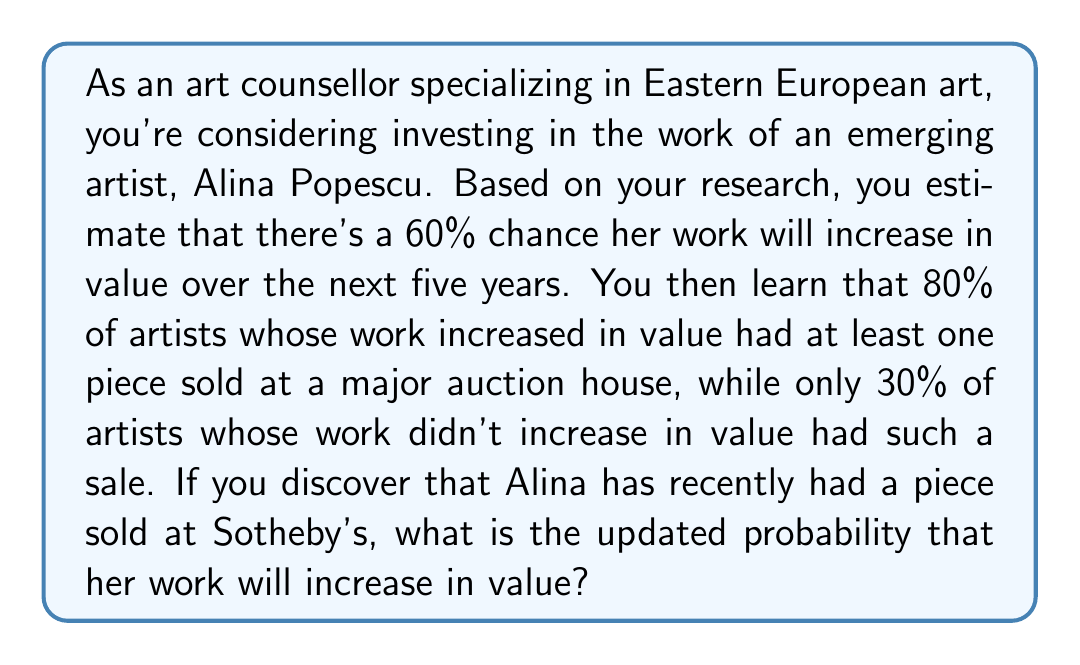Can you answer this question? This problem can be solved using Bayes' theorem. Let's define our events:

A: Alina's work increases in value
B: Alina has a piece sold at a major auction house

We're given:
$P(A) = 0.60$ (prior probability)
$P(B|A) = 0.80$ (probability of auction sale given value increase)
$P(B|\neg A) = 0.30$ (probability of auction sale given no value increase)
$P(B)$ (we've observed this event)

We want to find $P(A|B)$, the probability of value increase given the auction sale.

Bayes' theorem states:

$$P(A|B) = \frac{P(B|A) \cdot P(A)}{P(B)}$$

To find $P(B)$, we use the law of total probability:

$$P(B) = P(B|A) \cdot P(A) + P(B|\neg A) \cdot P(\neg A)$$

$$P(B) = 0.80 \cdot 0.60 + 0.30 \cdot (1 - 0.60) = 0.48 + 0.12 = 0.60$$

Now we can apply Bayes' theorem:

$$P(A|B) = \frac{0.80 \cdot 0.60}{0.60} = 0.80$$

Therefore, the updated probability that Alina's work will increase in value, given the auction sale, is 0.80 or 80%.
Answer: The updated probability that Alina Popescu's work will increase in value, given that she has had a piece sold at Sotheby's, is 0.80 or 80%. 